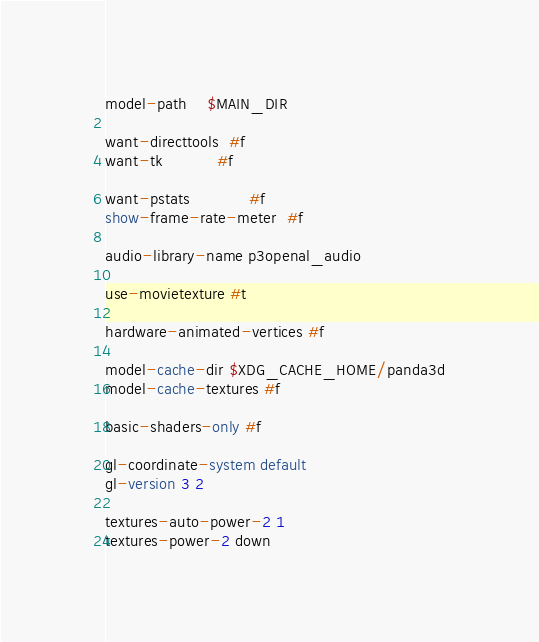<code> <loc_0><loc_0><loc_500><loc_500><_SQL_>model-path    $MAIN_DIR

want-directtools  #f
want-tk           #f

want-pstats            #f
show-frame-rate-meter  #f

audio-library-name p3openal_audio

use-movietexture #t

hardware-animated-vertices #f

model-cache-dir $XDG_CACHE_HOME/panda3d
model-cache-textures #f

basic-shaders-only #f

gl-coordinate-system default
gl-version 3 2

textures-auto-power-2 1
textures-power-2 down
</code> 